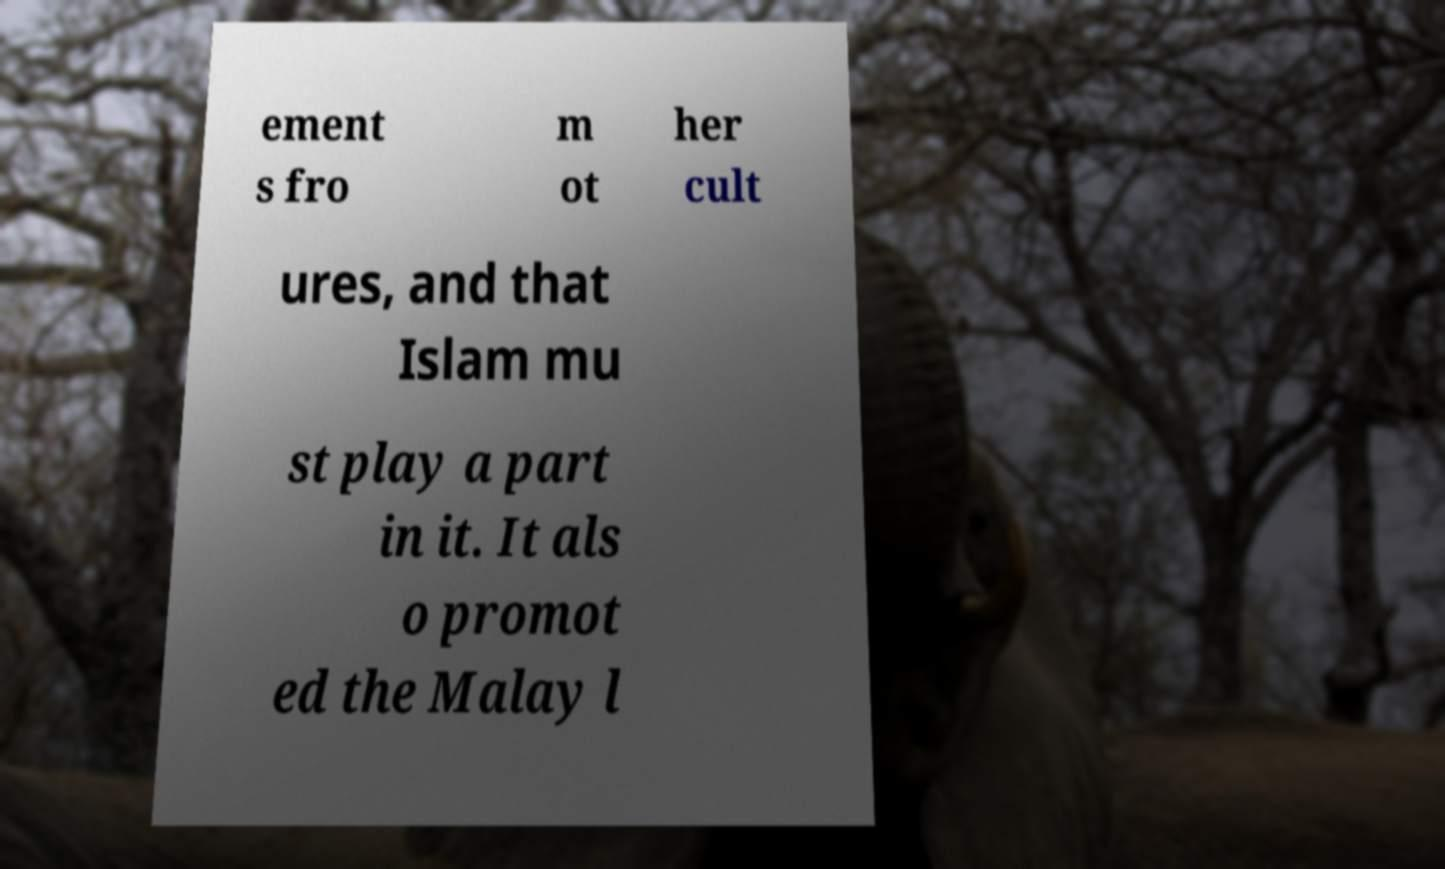Please read and relay the text visible in this image. What does it say? ement s fro m ot her cult ures, and that Islam mu st play a part in it. It als o promot ed the Malay l 